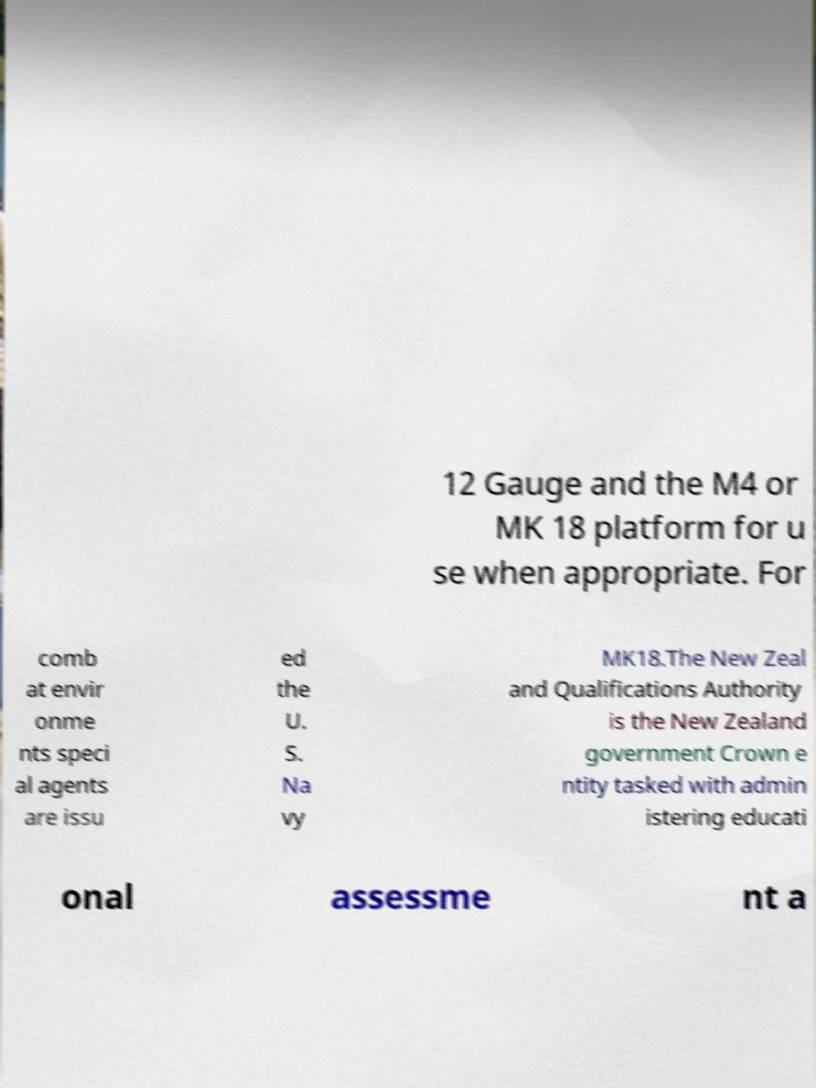Can you read and provide the text displayed in the image?This photo seems to have some interesting text. Can you extract and type it out for me? 12 Gauge and the M4 or MK 18 platform for u se when appropriate. For comb at envir onme nts speci al agents are issu ed the U. S. Na vy MK18.The New Zeal and Qualifications Authority is the New Zealand government Crown e ntity tasked with admin istering educati onal assessme nt a 